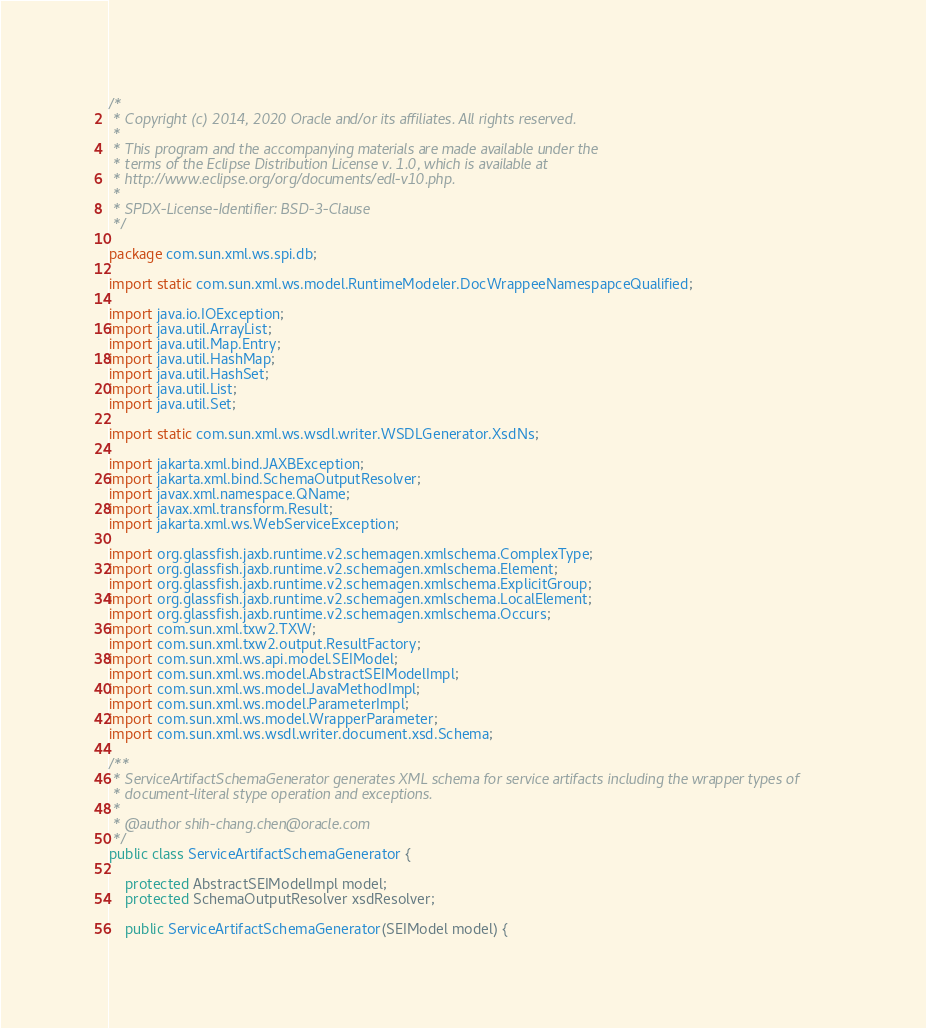Convert code to text. <code><loc_0><loc_0><loc_500><loc_500><_Java_>/*
 * Copyright (c) 2014, 2020 Oracle and/or its affiliates. All rights reserved.
 *
 * This program and the accompanying materials are made available under the
 * terms of the Eclipse Distribution License v. 1.0, which is available at
 * http://www.eclipse.org/org/documents/edl-v10.php.
 *
 * SPDX-License-Identifier: BSD-3-Clause
 */

package com.sun.xml.ws.spi.db;

import static com.sun.xml.ws.model.RuntimeModeler.DocWrappeeNamespapceQualified;

import java.io.IOException;
import java.util.ArrayList;
import java.util.Map.Entry;
import java.util.HashMap;
import java.util.HashSet;
import java.util.List;
import java.util.Set;

import static com.sun.xml.ws.wsdl.writer.WSDLGenerator.XsdNs;

import jakarta.xml.bind.JAXBException;
import jakarta.xml.bind.SchemaOutputResolver;
import javax.xml.namespace.QName;
import javax.xml.transform.Result;
import jakarta.xml.ws.WebServiceException;

import org.glassfish.jaxb.runtime.v2.schemagen.xmlschema.ComplexType;
import org.glassfish.jaxb.runtime.v2.schemagen.xmlschema.Element;
import org.glassfish.jaxb.runtime.v2.schemagen.xmlschema.ExplicitGroup;
import org.glassfish.jaxb.runtime.v2.schemagen.xmlschema.LocalElement;
import org.glassfish.jaxb.runtime.v2.schemagen.xmlschema.Occurs;
import com.sun.xml.txw2.TXW;
import com.sun.xml.txw2.output.ResultFactory;
import com.sun.xml.ws.api.model.SEIModel;
import com.sun.xml.ws.model.AbstractSEIModelImpl;
import com.sun.xml.ws.model.JavaMethodImpl;
import com.sun.xml.ws.model.ParameterImpl;
import com.sun.xml.ws.model.WrapperParameter;
import com.sun.xml.ws.wsdl.writer.document.xsd.Schema;

/**
 * ServiceArtifactSchemaGenerator generates XML schema for service artifacts including the wrapper types of 
 * document-literal stype operation and exceptions.
 * 
 * @author shih-chang.chen@oracle.com
 */
public class ServiceArtifactSchemaGenerator {

    protected AbstractSEIModelImpl model;
    protected SchemaOutputResolver xsdResolver;
    
    public ServiceArtifactSchemaGenerator(SEIModel model) {</code> 